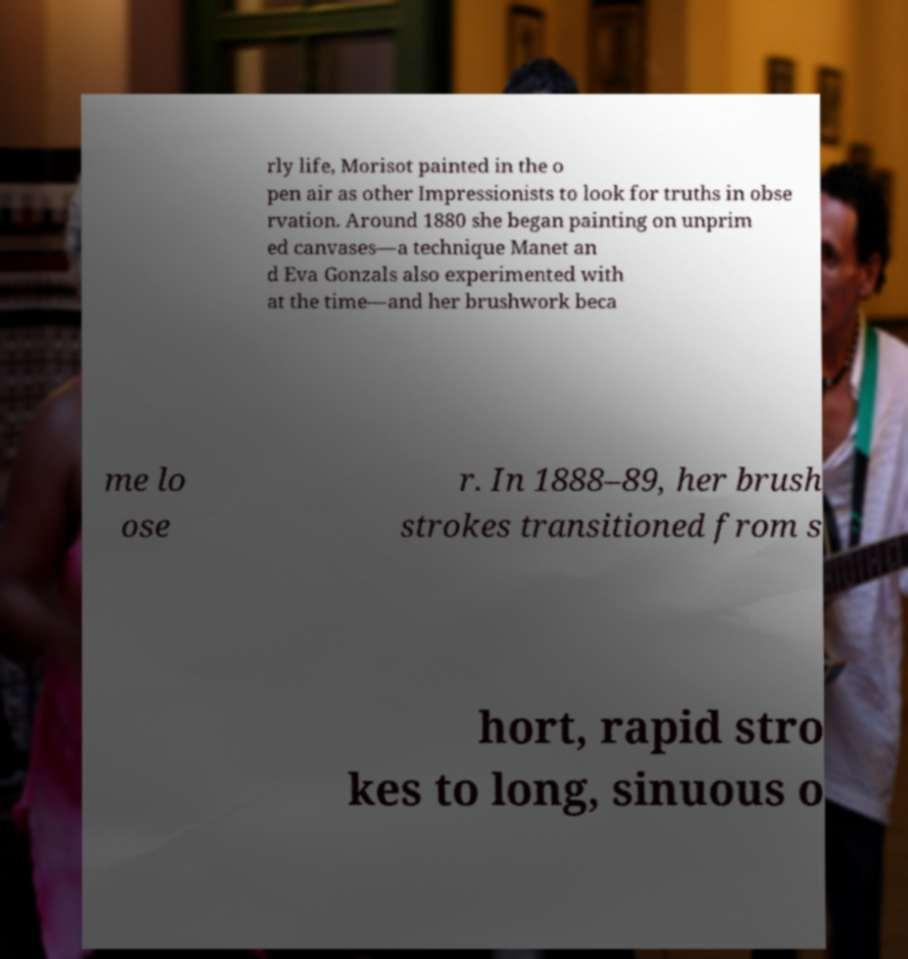Could you assist in decoding the text presented in this image and type it out clearly? rly life, Morisot painted in the o pen air as other Impressionists to look for truths in obse rvation. Around 1880 she began painting on unprim ed canvases—a technique Manet an d Eva Gonzals also experimented with at the time—and her brushwork beca me lo ose r. In 1888–89, her brush strokes transitioned from s hort, rapid stro kes to long, sinuous o 